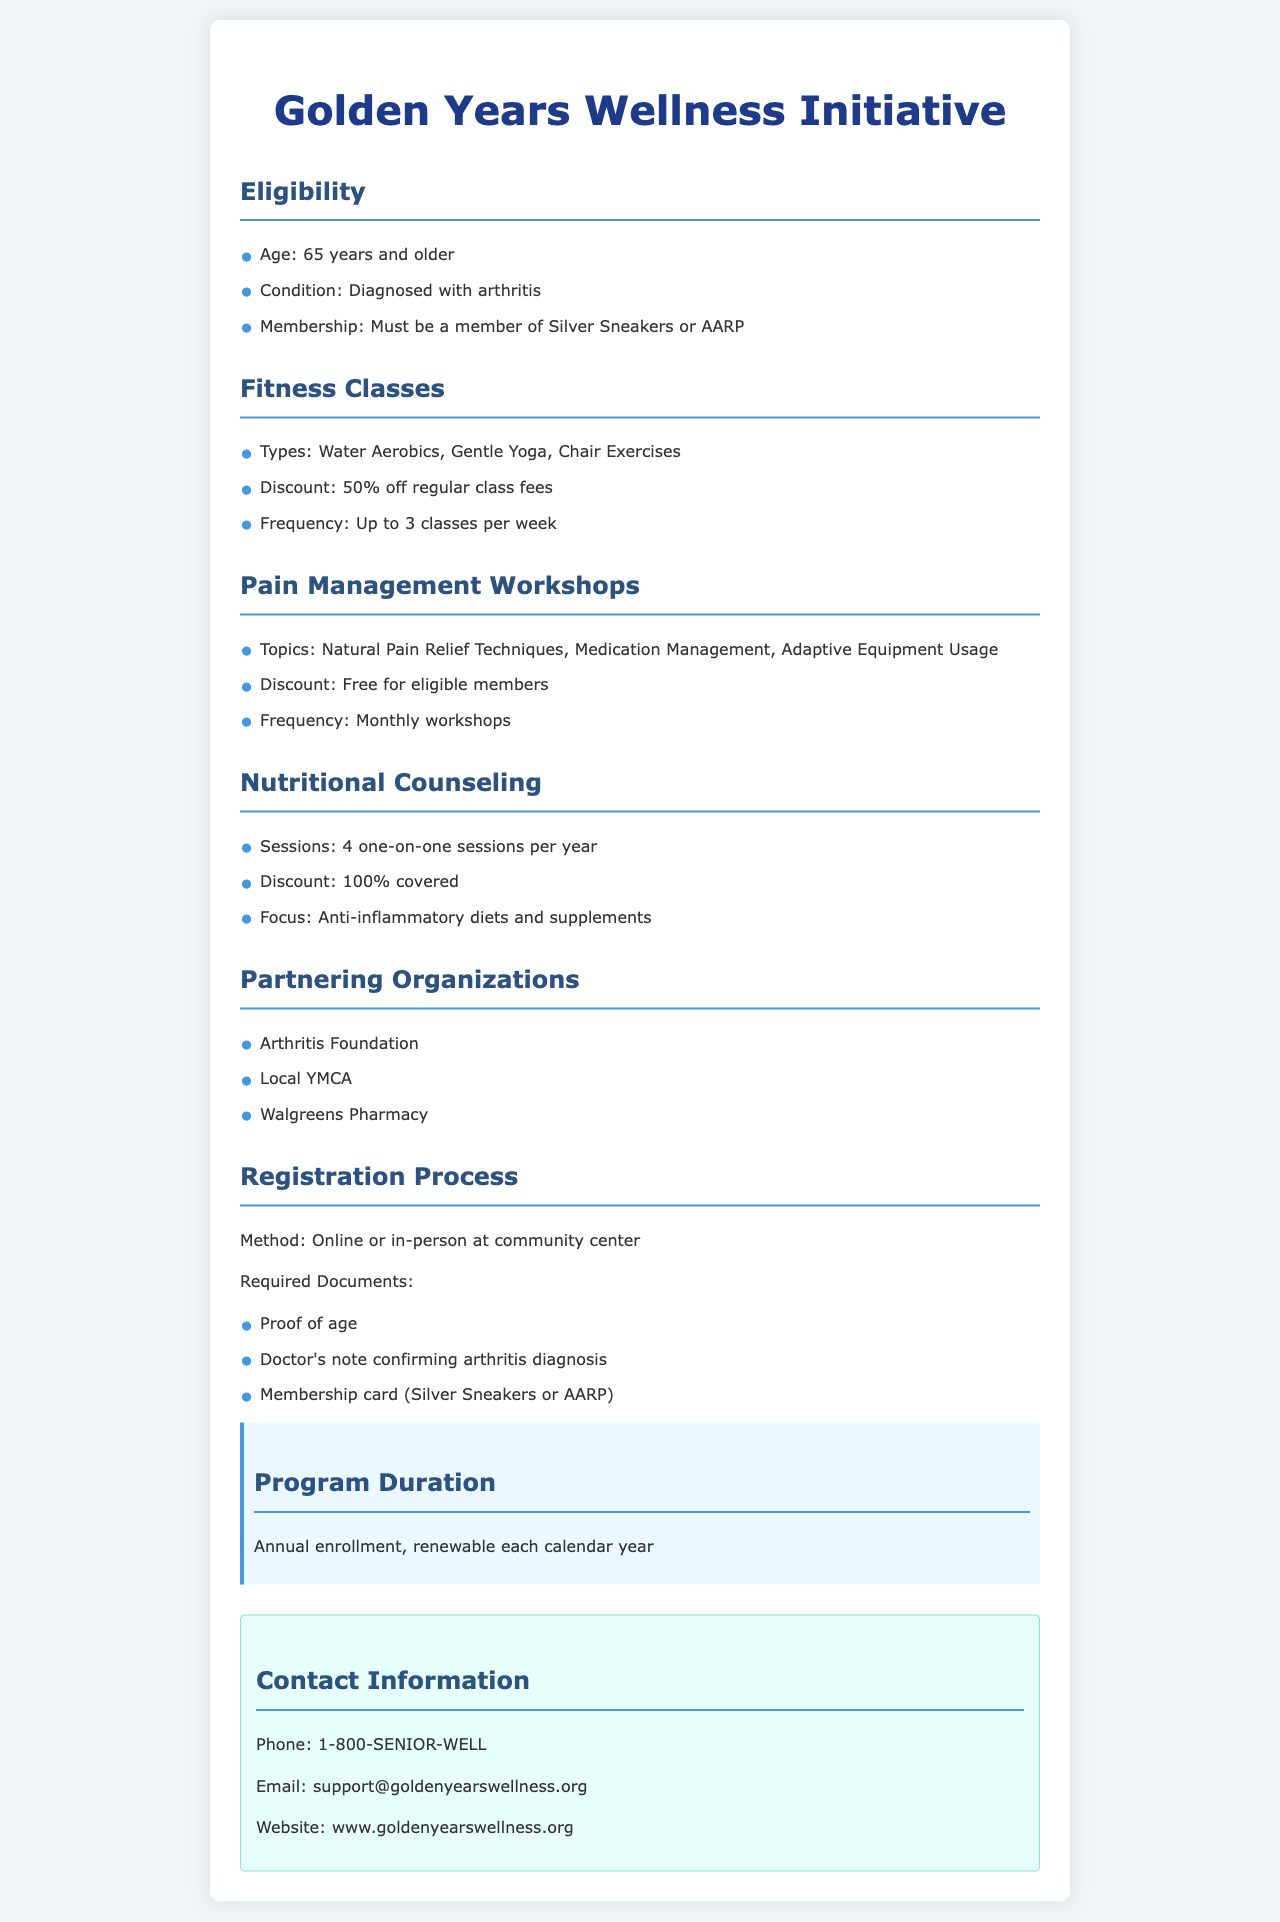What is the age requirement for eligibility? The eligibility requires individuals to be 65 years and older.
Answer: 65 years What types of fitness classes are offered? The document lists the types of fitness classes offered under the Fitness Classes section.
Answer: Water Aerobics, Gentle Yoga, Chair Exercises What is the discount for Pain Management Workshops? The document states the cost for eligible members for Pain Management Workshops.
Answer: Free How many one-on-one nutritional counseling sessions are covered each year? The document outlines how many sessions are provided under Nutritional Counseling.
Answer: 4 Which organizations are partnering in this initiative? The document provides a list of partnering organizations in the relevant section.
Answer: Arthritis Foundation, Local YMCA, Walgreens Pharmacy What is the registration method for the program? The document mentions the methods of registration available for participants.
Answer: Online or in-person What focus does the Nutritional Counseling have? The document specifies the focus area of the Nutritional Counseling offered to members.
Answer: Anti-inflammatory diets and supplements How often are the Pain Management Workshops held? The frequency of the workshops is specified in the Pain Management Workshops section of the document.
Answer: Monthly What is required as proof of eligibility? The document lists required documents for eligibility verification in the Registration Process section.
Answer: Proof of age, Doctor's note, Membership card 